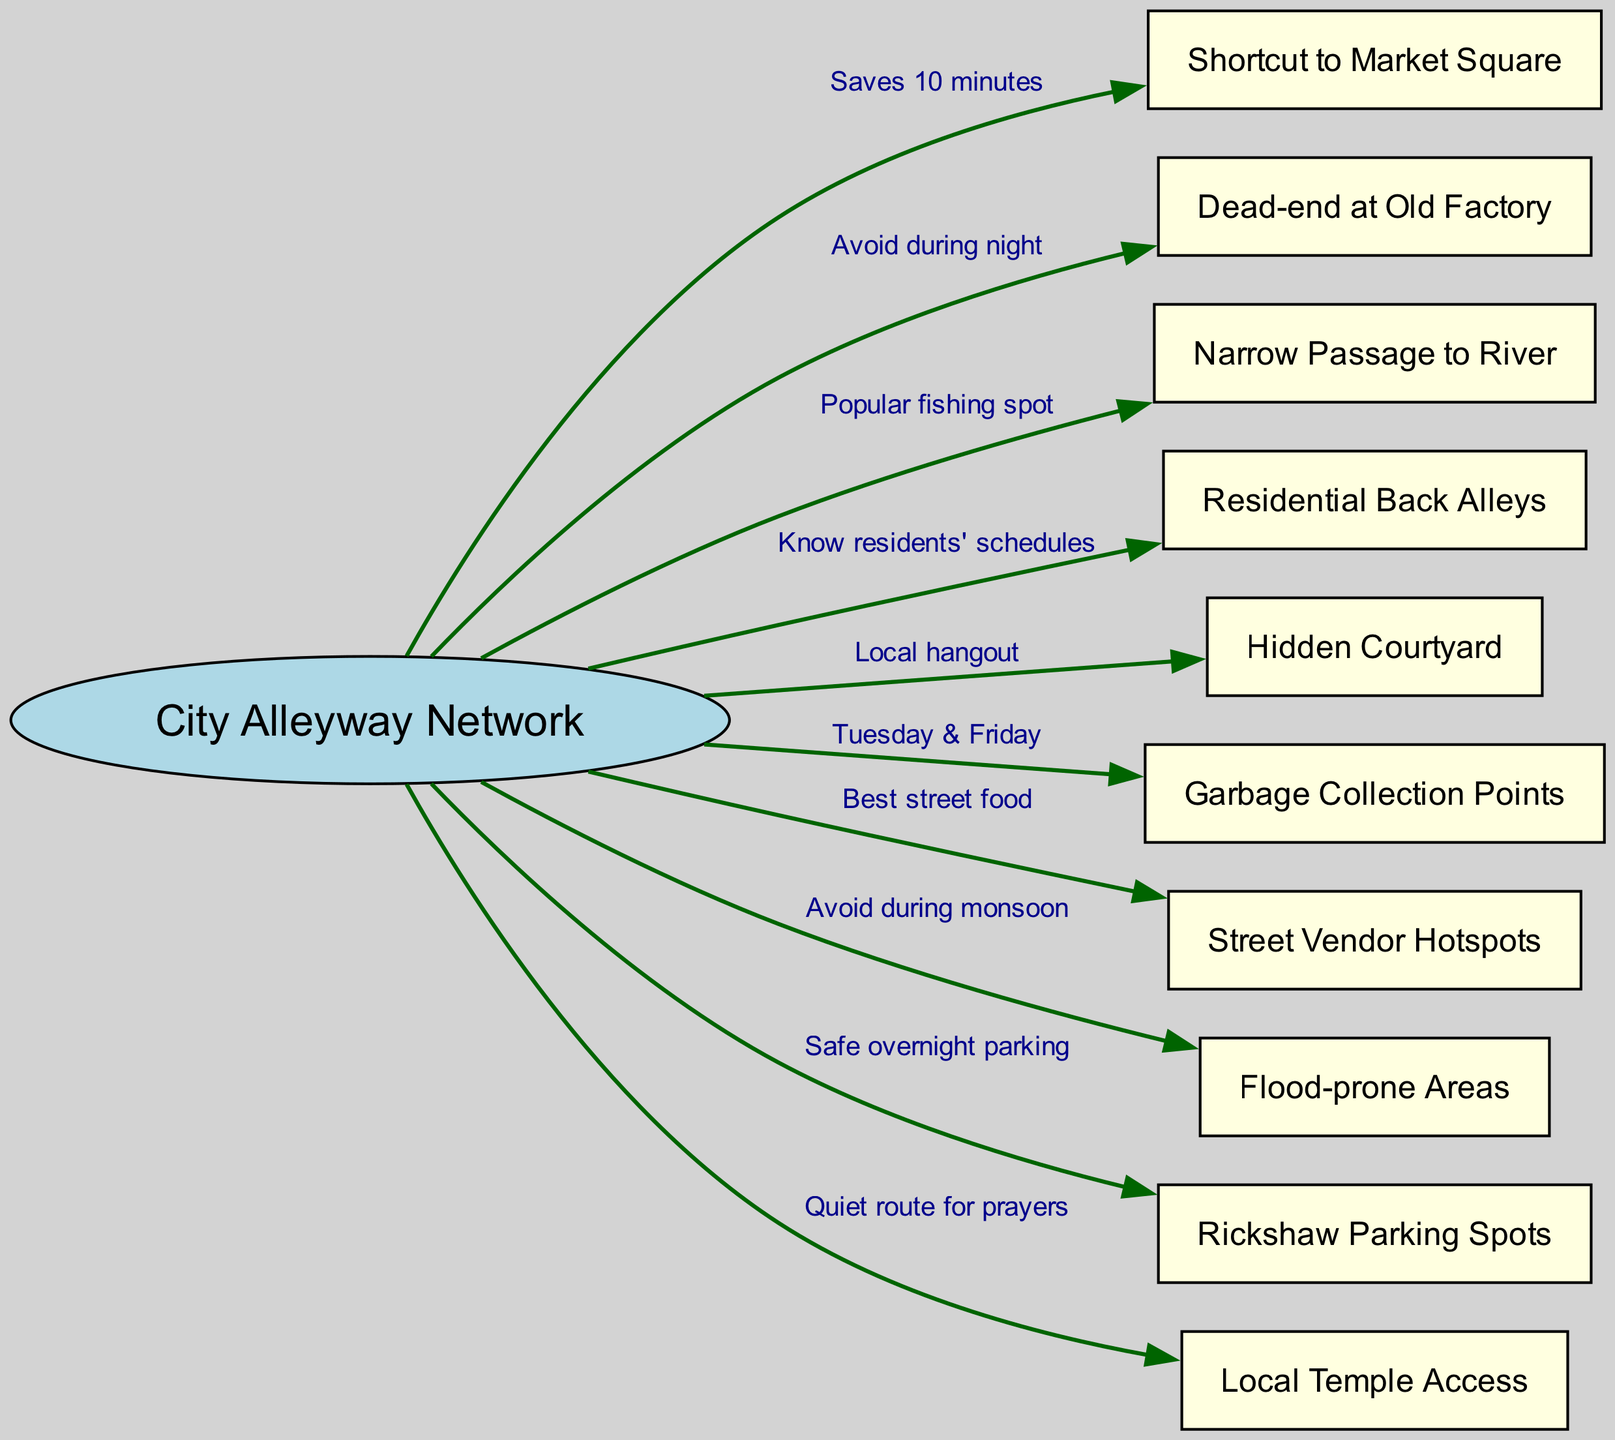What is the central concept of the diagram? The diagram clearly states the central concept at the top, which is "City Alleyway Network".
Answer: City Alleyway Network How many nodes are connected to the central concept? By counting the number of unique nodes listed that connect to the central concept, there are ten nodes in total.
Answer: 10 What is the shortcut to the Market Square labeled as? The edge connecting the "City Alleyway Network" to "Shortcut to Market Square" has a label stating "Saves 10 minutes".
Answer: Saves 10 minutes Which area should be avoided during the night? The diagram indicates that the "Dead-end at Old Factory" should be avoided at night as per its connection label.
Answer: Dead-end at Old Factory What is the purpose of the "Narrow Passage to River"? The connection label shows that the "Narrow Passage to River" is described as a "Popular fishing spot," indicating its use.
Answer: Popular fishing spot What are the days for garbage collection points? The "Garbage Collection Points" are connected to the central concept with a label specifying "Tuesday & Friday".
Answer: Tuesday & Friday Which areas should be avoided during monsoon? According to the label on the connection, "Flood-prone Areas" are noted as areas to avoid during the monsoon.
Answer: Flood-prone Areas What is the safest option for rickshaw parking overnight? The diagram shows that "Rickshaw Parking Spots" are noted as "Safe overnight parking", highlighting its suitability for rickshaw pullers.
Answer: Safe overnight parking How does one access the local temple? The connection to "Local Temple Access" lists it as a "Quiet route for prayers", providing clear access information for its users.
Answer: Quiet route for prayers What is the purpose of the "Hidden Courtyard"? The "Hidden Courtyard" is identified in the diagram as a "Local hangout", indicating its function within the network.
Answer: Local hangout 